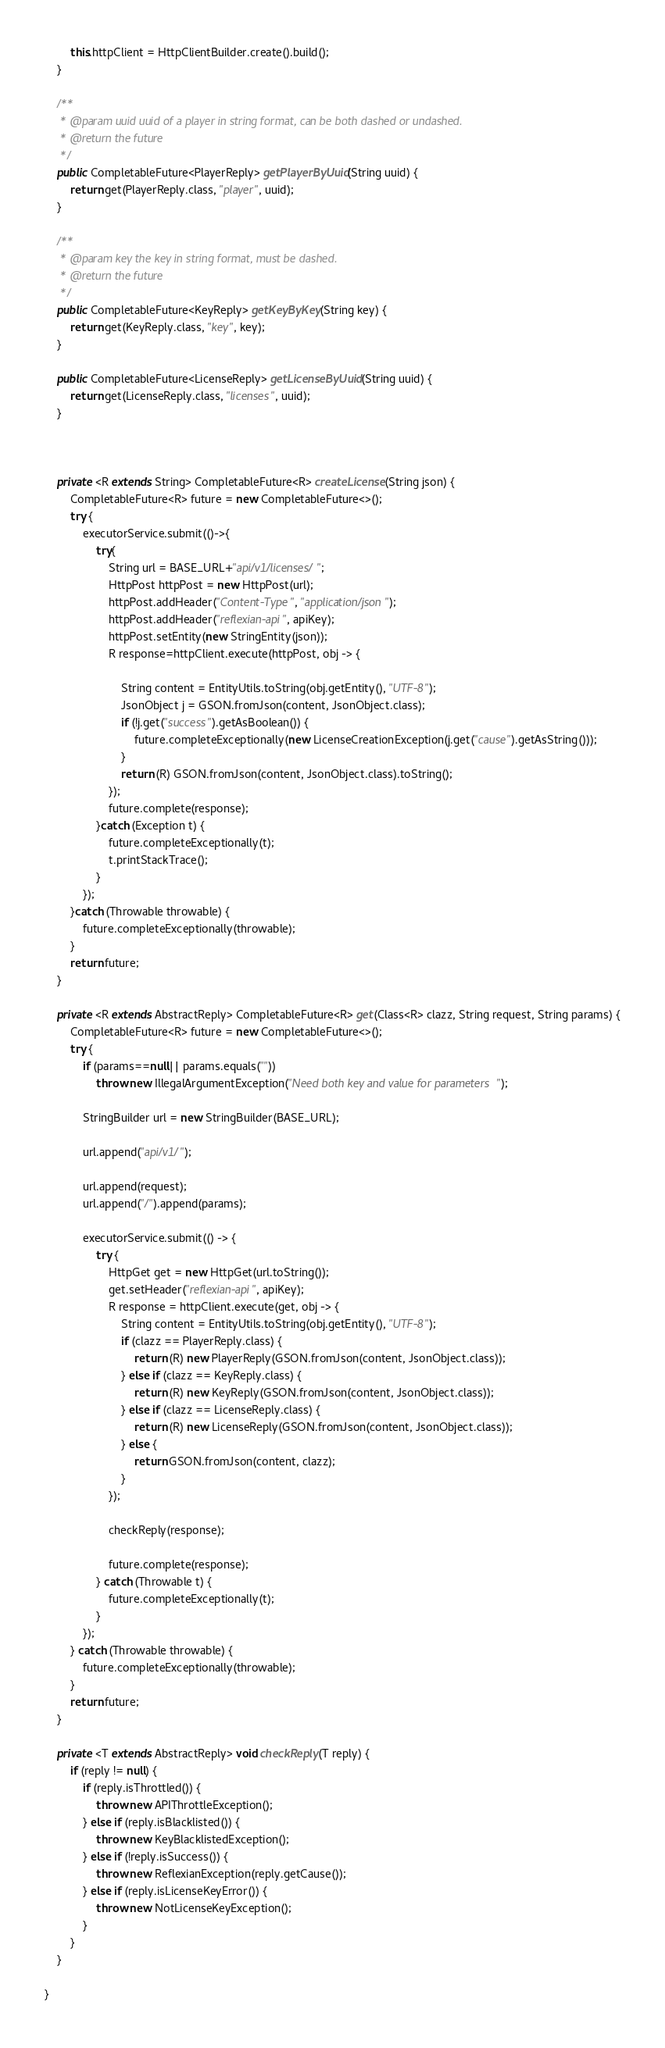<code> <loc_0><loc_0><loc_500><loc_500><_Java_>        this.httpClient = HttpClientBuilder.create().build();
    }

    /**
     * @param uuid uuid of a player in string format, can be both dashed or undashed.
     * @return the future
     */
    public CompletableFuture<PlayerReply> getPlayerByUuid(String uuid) {
        return get(PlayerReply.class, "player", uuid);
    }

    /**
     * @param key the key in string format, must be dashed.
     * @return the future
     */
    public CompletableFuture<KeyReply> getKeyByKey(String key) {
        return get(KeyReply.class, "key", key);
    }

    public CompletableFuture<LicenseReply> getLicenseByUuid(String uuid) {
        return get(LicenseReply.class, "licenses", uuid);
    }



    private <R extends String> CompletableFuture<R> createLicense(String json) {
        CompletableFuture<R> future = new CompletableFuture<>();
        try {
            executorService.submit(()->{
                try{
                    String url = BASE_URL+"api/v1/licenses/";
                    HttpPost httpPost = new HttpPost(url);
                    httpPost.addHeader("Content-Type", "application/json");
                    httpPost.addHeader("reflexian-api", apiKey);
                    httpPost.setEntity(new StringEntity(json));
                    R response=httpClient.execute(httpPost, obj -> {

                        String content = EntityUtils.toString(obj.getEntity(), "UTF-8");
                        JsonObject j = GSON.fromJson(content, JsonObject.class);
                        if (!j.get("success").getAsBoolean()) {
                            future.completeExceptionally(new LicenseCreationException(j.get("cause").getAsString()));
                        }
                        return (R) GSON.fromJson(content, JsonObject.class).toString();
                    });
                    future.complete(response);
                }catch (Exception t) {
                    future.completeExceptionally(t);
                    t.printStackTrace();
                }
            });
        }catch (Throwable throwable) {
            future.completeExceptionally(throwable);
        }
        return future;
    }

    private <R extends AbstractReply> CompletableFuture<R> get(Class<R> clazz, String request, String params) {
        CompletableFuture<R> future = new CompletableFuture<>();
        try {
            if (params==null|| params.equals(""))
                throw new IllegalArgumentException("Need both key and value for parameters");

            StringBuilder url = new StringBuilder(BASE_URL);

            url.append("api/v1/");

            url.append(request);
            url.append("/").append(params);

            executorService.submit(() -> {
                try {
                    HttpGet get = new HttpGet(url.toString());
                    get.setHeader("reflexian-api", apiKey);
                    R response = httpClient.execute(get, obj -> {
                        String content = EntityUtils.toString(obj.getEntity(), "UTF-8");
                        if (clazz == PlayerReply.class) {
                            return (R) new PlayerReply(GSON.fromJson(content, JsonObject.class));
                        } else if (clazz == KeyReply.class) {
                            return (R) new KeyReply(GSON.fromJson(content, JsonObject.class));
                        } else if (clazz == LicenseReply.class) {
                            return (R) new LicenseReply(GSON.fromJson(content, JsonObject.class));
                        } else {
                            return GSON.fromJson(content, clazz);
                        }
                    });

                    checkReply(response);

                    future.complete(response);
                } catch (Throwable t) {
                    future.completeExceptionally(t);
                }
            });
        } catch (Throwable throwable) {
            future.completeExceptionally(throwable);
        }
        return future;
    }

    private <T extends AbstractReply> void checkReply(T reply) {
        if (reply != null) {
            if (reply.isThrottled()) {
                throw new APIThrottleException();
            } else if (reply.isBlacklisted()) {
                throw new KeyBlacklistedException();
            } else if (!reply.isSuccess()) {
                throw new ReflexianException(reply.getCause());
            } else if (reply.isLicenseKeyError()) {
                throw new NotLicenseKeyException();
            }
        }
    }

}
</code> 